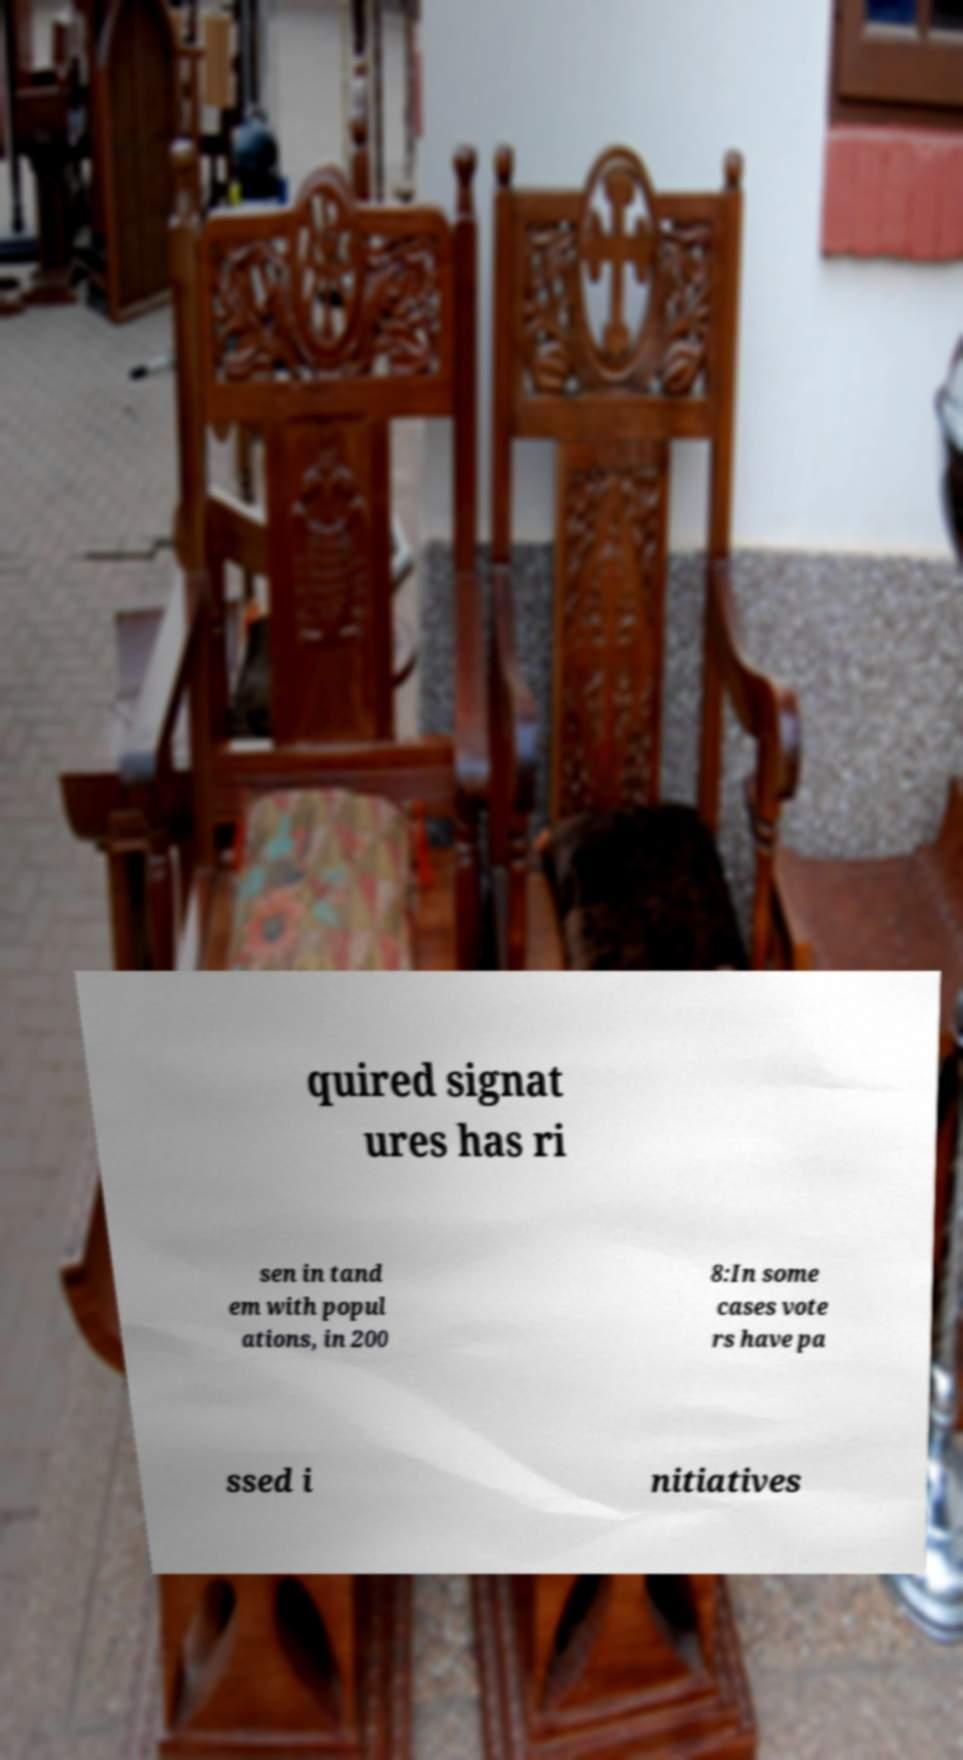What messages or text are displayed in this image? I need them in a readable, typed format. quired signat ures has ri sen in tand em with popul ations, in 200 8:In some cases vote rs have pa ssed i nitiatives 